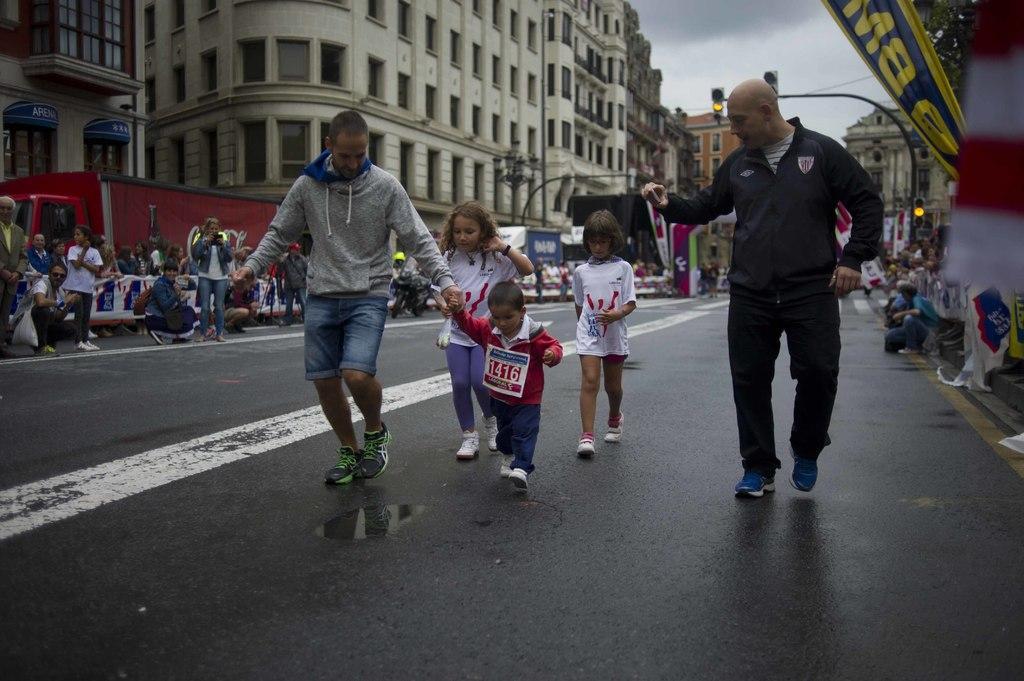Describe this image in one or two sentences. On the right side a man is walking on the road, he wore black color coat, trouser. In the middle 3 children are walking on the road, on the left side a woman is standing and taking the video of this, there are buildings in this image. 